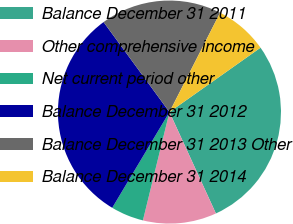Convert chart. <chart><loc_0><loc_0><loc_500><loc_500><pie_chart><fcel>Balance December 31 2011<fcel>Other comprehensive income<fcel>Net current period other<fcel>Balance December 31 2012<fcel>Balance December 31 2013 Other<fcel>Balance December 31 2014<nl><fcel>27.96%<fcel>10.66%<fcel>4.75%<fcel>31.37%<fcel>17.56%<fcel>7.7%<nl></chart> 